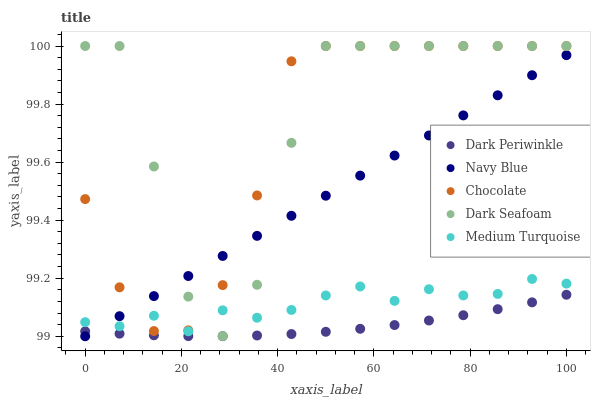Does Dark Periwinkle have the minimum area under the curve?
Answer yes or no. Yes. Does Dark Seafoam have the maximum area under the curve?
Answer yes or no. Yes. Does Dark Seafoam have the minimum area under the curve?
Answer yes or no. No. Does Dark Periwinkle have the maximum area under the curve?
Answer yes or no. No. Is Navy Blue the smoothest?
Answer yes or no. Yes. Is Dark Seafoam the roughest?
Answer yes or no. Yes. Is Dark Periwinkle the smoothest?
Answer yes or no. No. Is Dark Periwinkle the roughest?
Answer yes or no. No. Does Navy Blue have the lowest value?
Answer yes or no. Yes. Does Dark Seafoam have the lowest value?
Answer yes or no. No. Does Chocolate have the highest value?
Answer yes or no. Yes. Does Dark Periwinkle have the highest value?
Answer yes or no. No. Is Dark Periwinkle less than Dark Seafoam?
Answer yes or no. Yes. Is Dark Seafoam greater than Dark Periwinkle?
Answer yes or no. Yes. Does Dark Periwinkle intersect Navy Blue?
Answer yes or no. Yes. Is Dark Periwinkle less than Navy Blue?
Answer yes or no. No. Is Dark Periwinkle greater than Navy Blue?
Answer yes or no. No. Does Dark Periwinkle intersect Dark Seafoam?
Answer yes or no. No. 